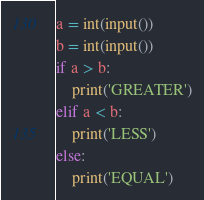<code> <loc_0><loc_0><loc_500><loc_500><_Python_>a = int(input())
b = int(input())
if a > b:
    print('GREATER')
elif a < b:
    print('LESS')
else:
    print('EQUAL')</code> 